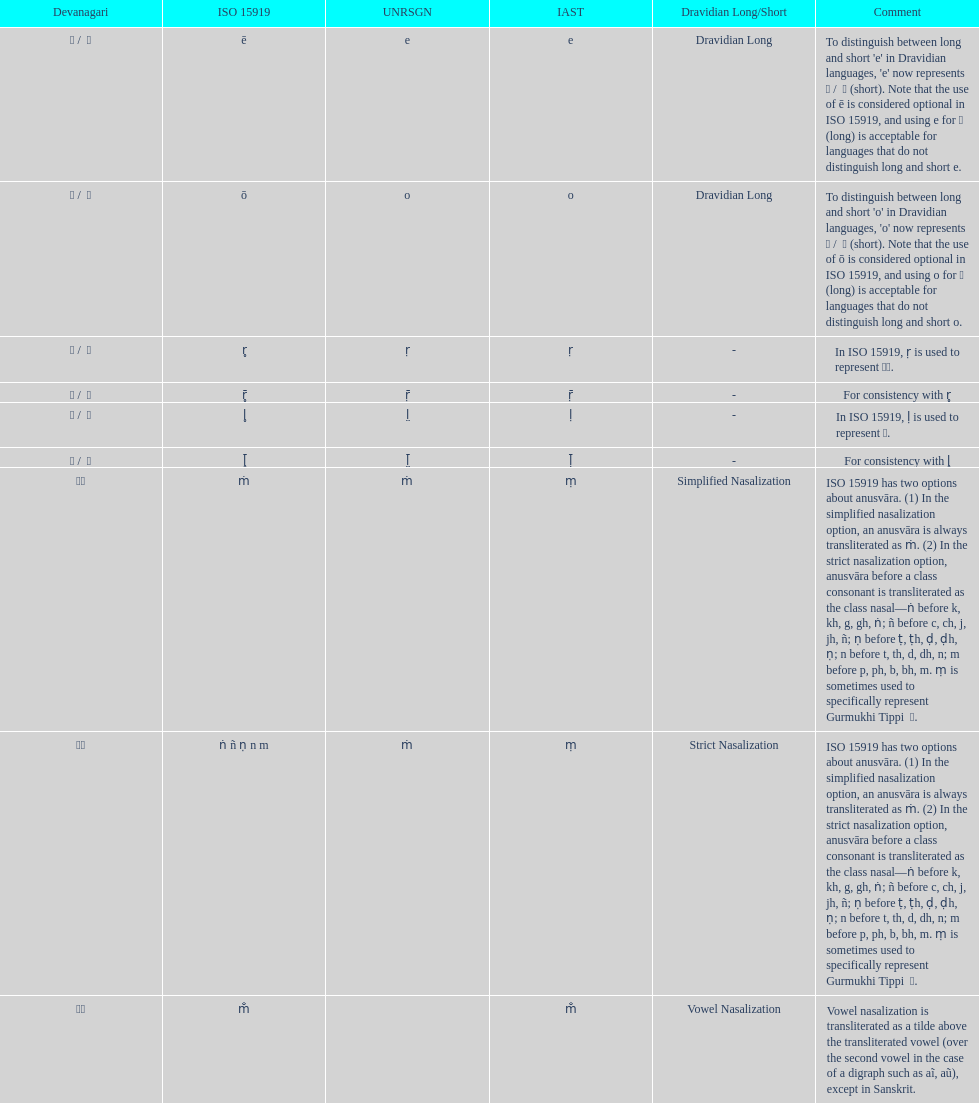What is listed previous to in iso 15919, &#7735; is used to represent &#2355;. under comments? For consistency with r̥. Parse the full table. {'header': ['Devanagari', 'ISO 15919', 'UNRSGN', 'IAST', 'Dravidian Long/Short', 'Comment'], 'rows': [['ए / \xa0े', 'ē', 'e', 'e', 'Dravidian Long', "To distinguish between long and short 'e' in Dravidian languages, 'e' now represents ऎ / \xa0ॆ (short). Note that the use of ē is considered optional in ISO 15919, and using e for ए (long) is acceptable for languages that do not distinguish long and short e."], ['ओ / \xa0ो', 'ō', 'o', 'o', 'Dravidian Long', "To distinguish between long and short 'o' in Dravidian languages, 'o' now represents ऒ / \xa0ॊ (short). Note that the use of ō is considered optional in ISO 15919, and using o for ओ (long) is acceptable for languages that do not distinguish long and short o."], ['ऋ / \xa0ृ', 'r̥', 'ṛ', 'ṛ', '-', 'In ISO 15919, ṛ is used to represent ड़.'], ['ॠ / \xa0ॄ', 'r̥̄', 'ṝ', 'ṝ', '-', 'For consistency with r̥'], ['ऌ / \xa0ॢ', 'l̥', 'l̤', 'ḷ', '-', 'In ISO 15919, ḷ is used to represent ळ.'], ['ॡ / \xa0ॣ', 'l̥̄', 'l̤̄', 'ḹ', '-', 'For consistency with l̥'], ['◌ं', 'ṁ', 'ṁ', 'ṃ', 'Simplified Nasalization', 'ISO 15919 has two options about anusvāra. (1) In the simplified nasalization option, an anusvāra is always transliterated as ṁ. (2) In the strict nasalization option, anusvāra before a class consonant is transliterated as the class nasal—ṅ before k, kh, g, gh, ṅ; ñ before c, ch, j, jh, ñ; ṇ before ṭ, ṭh, ḍ, ḍh, ṇ; n before t, th, d, dh, n; m before p, ph, b, bh, m. ṃ is sometimes used to specifically represent Gurmukhi Tippi \xa0ੰ.'], ['◌ं', 'ṅ ñ ṇ n m', 'ṁ', 'ṃ', 'Strict Nasalization', 'ISO 15919 has two options about anusvāra. (1) In the simplified nasalization option, an anusvāra is always transliterated as ṁ. (2) In the strict nasalization option, anusvāra before a class consonant is transliterated as the class nasal—ṅ before k, kh, g, gh, ṅ; ñ before c, ch, j, jh, ñ; ṇ before ṭ, ṭh, ḍ, ḍh, ṇ; n before t, th, d, dh, n; m before p, ph, b, bh, m. ṃ is sometimes used to specifically represent Gurmukhi Tippi \xa0ੰ.'], ['◌ँ', 'm̐', '', 'm̐', 'Vowel Nasalization', 'Vowel nasalization is transliterated as a tilde above the transliterated vowel (over the second vowel in the case of a digraph such as aĩ, aũ), except in Sanskrit.']]} 